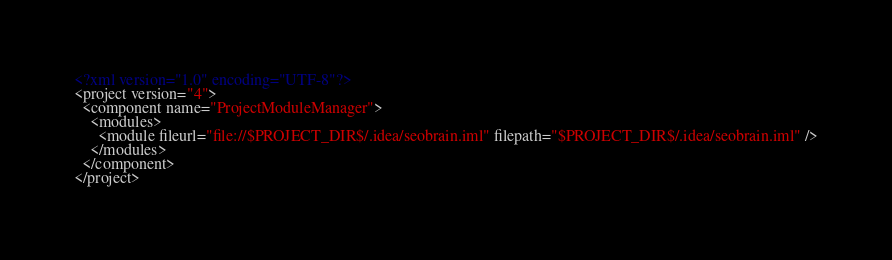<code> <loc_0><loc_0><loc_500><loc_500><_XML_><?xml version="1.0" encoding="UTF-8"?>
<project version="4">
  <component name="ProjectModuleManager">
    <modules>
      <module fileurl="file://$PROJECT_DIR$/.idea/seobrain.iml" filepath="$PROJECT_DIR$/.idea/seobrain.iml" />
    </modules>
  </component>
</project></code> 